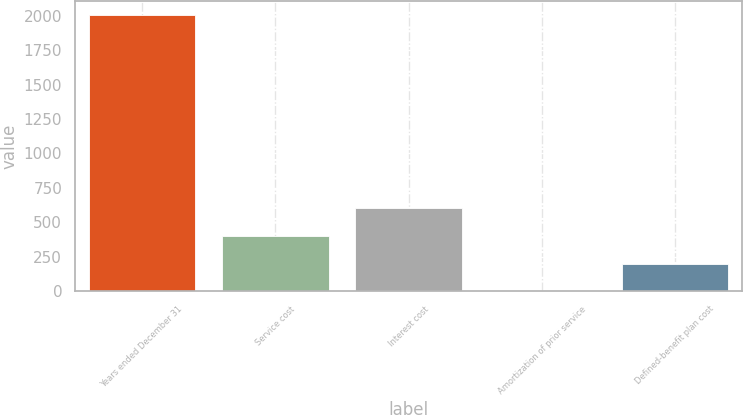Convert chart. <chart><loc_0><loc_0><loc_500><loc_500><bar_chart><fcel>Years ended December 31<fcel>Service cost<fcel>Interest cost<fcel>Amortization of prior service<fcel>Defined-benefit plan cost<nl><fcel>2004<fcel>401.12<fcel>601.48<fcel>0.4<fcel>200.76<nl></chart> 